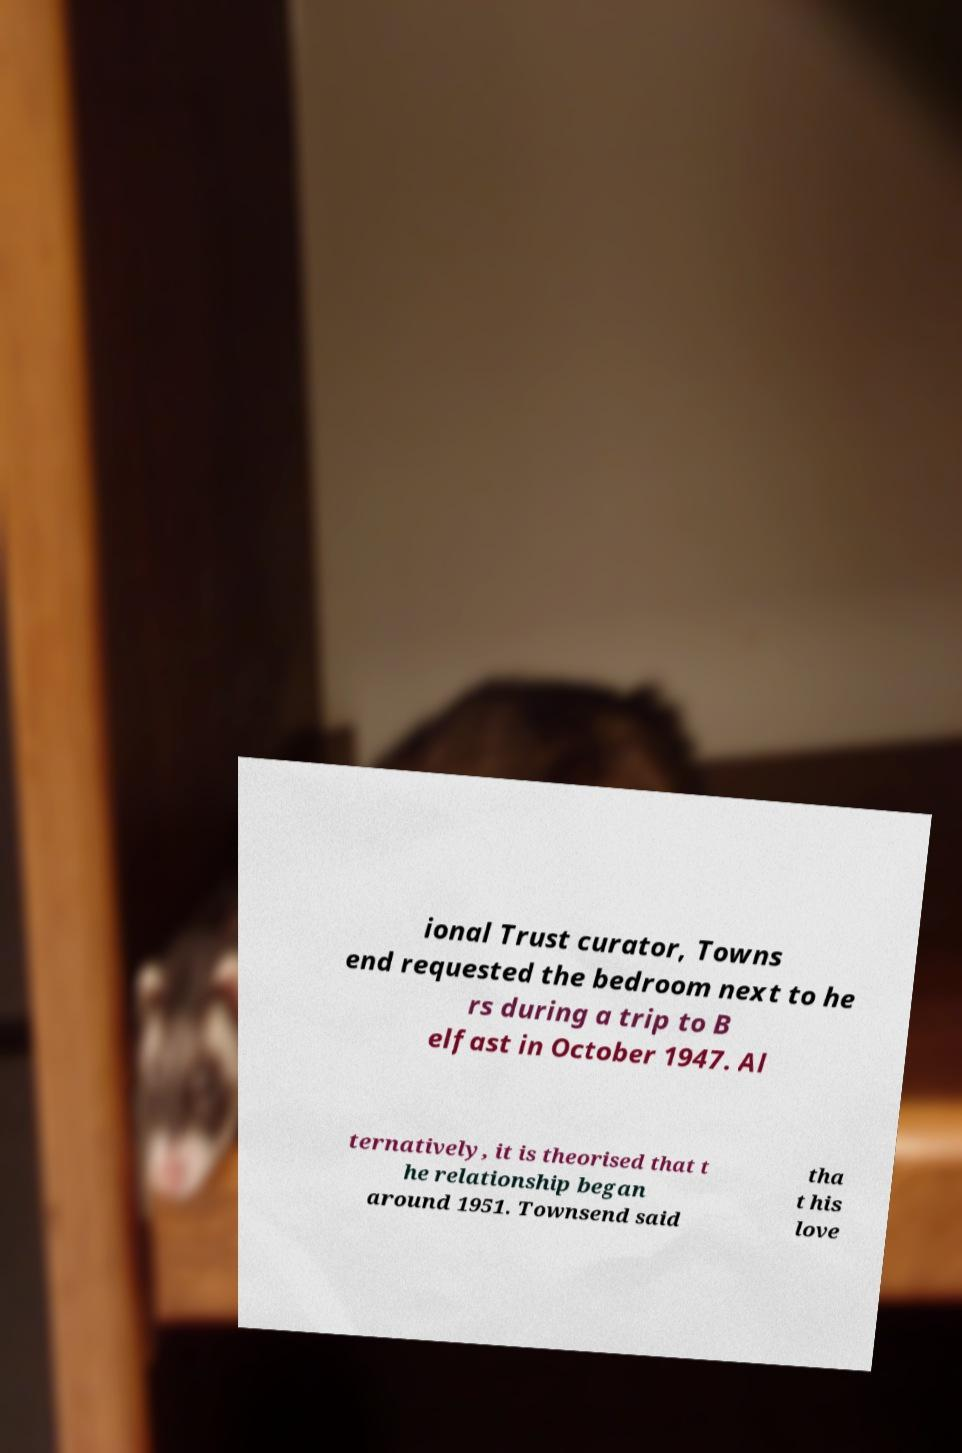Could you assist in decoding the text presented in this image and type it out clearly? ional Trust curator, Towns end requested the bedroom next to he rs during a trip to B elfast in October 1947. Al ternatively, it is theorised that t he relationship began around 1951. Townsend said tha t his love 